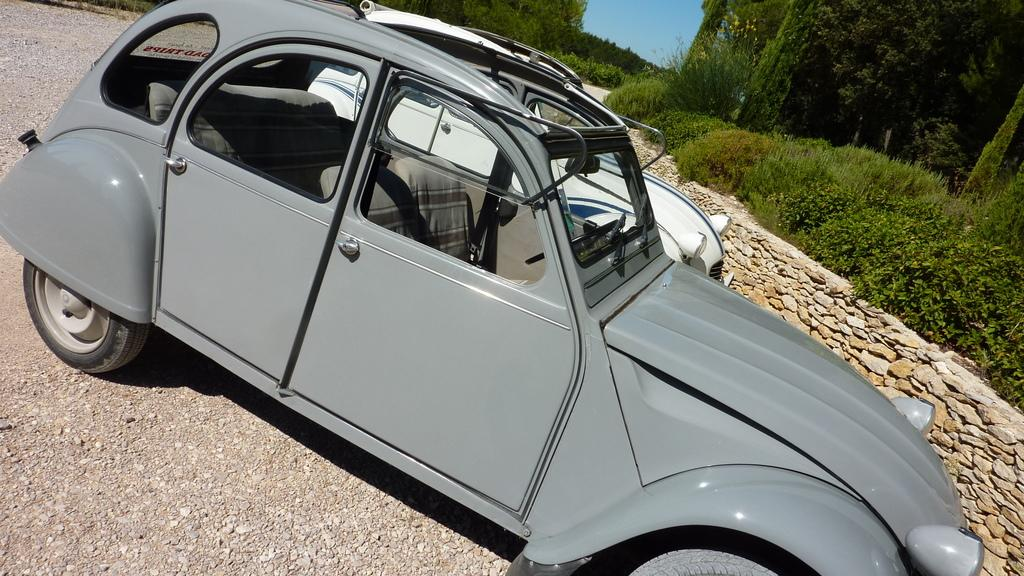What vehicles are located in the middle of the image? There are two cars in the middle of the image. What type of vegetation can be seen in the background of the image? There are plants and trees in the background of the image. What color is the sky in the image? The sky is blue and visible at the top of the image. Where is the volleyball court located in the image? There is no volleyball court present in the image. What thoughts are going through the mind of the car in the image? Cars do not have minds, so it is not possible to determine their thoughts. 